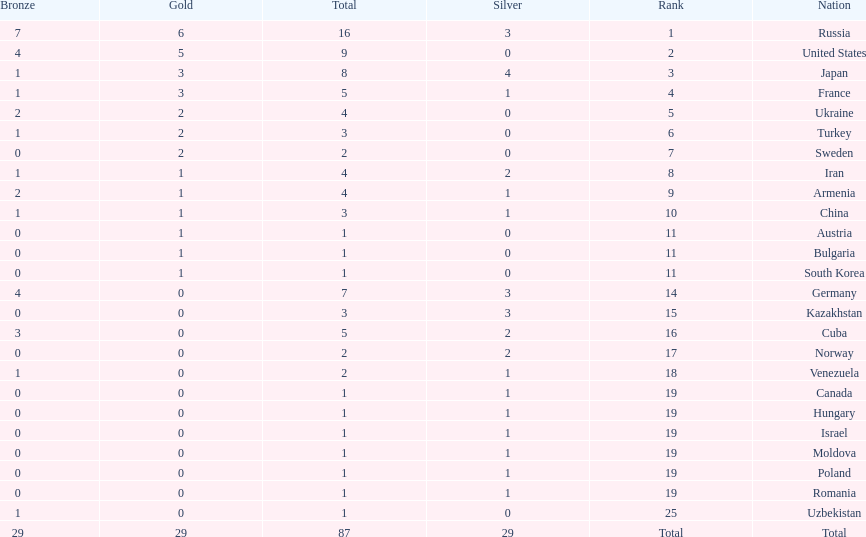Which nation has one gold medal but zero in both silver and bronze? Austria. 